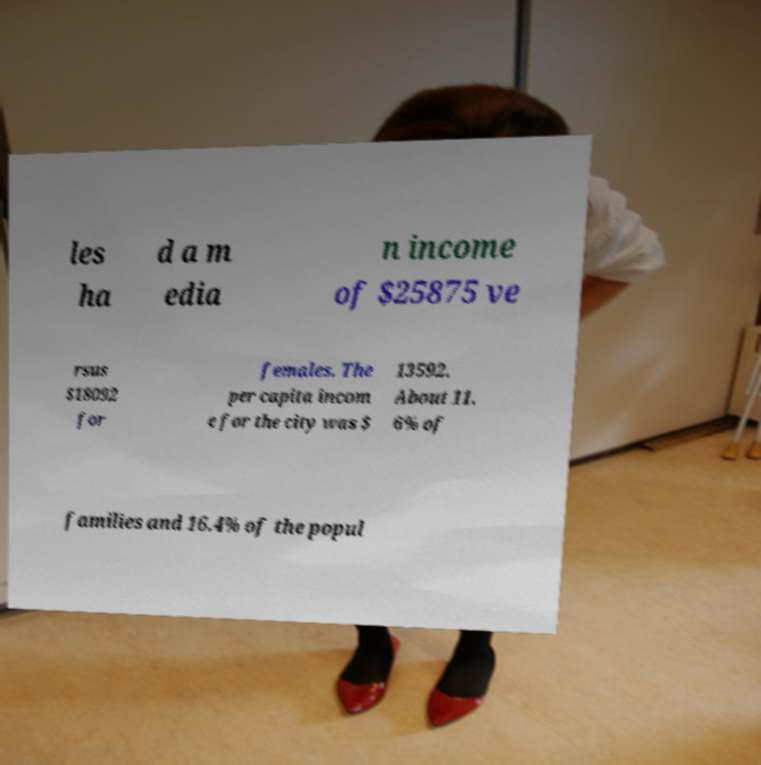Please read and relay the text visible in this image. What does it say? les ha d a m edia n income of $25875 ve rsus $18092 for females. The per capita incom e for the city was $ 13592. About 11. 6% of families and 16.4% of the popul 